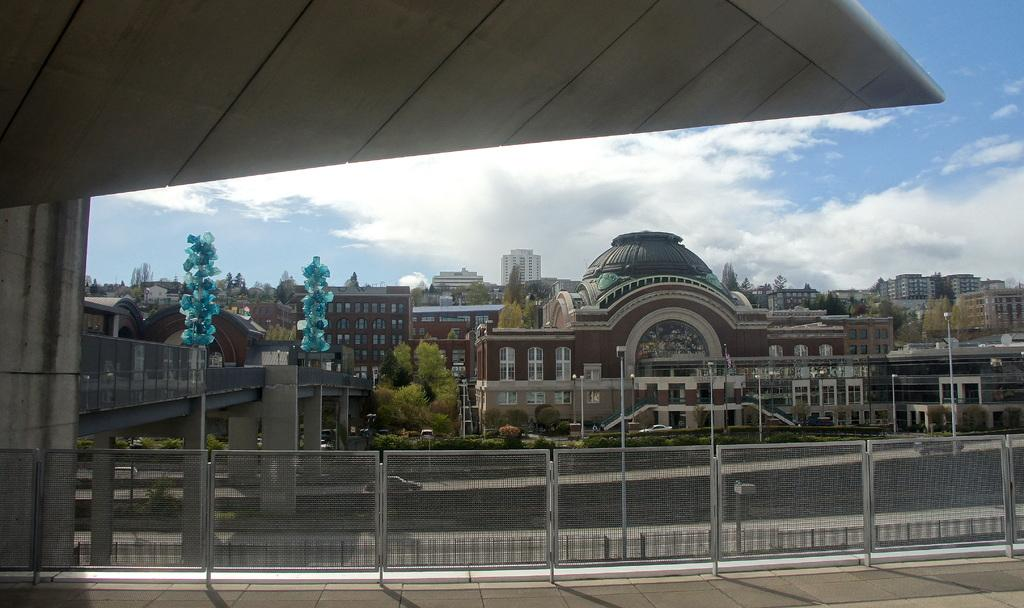What type of structures can be seen in the image? There are gates and buildings in the image. What other objects are present in the image? There are poles and trees in the image. What is visible in the sky at the top of the image? There are clouds visible in the sky at the top of the image. What type of produce is being discovered by the pig in the image? There is no pig or produce present in the image. 